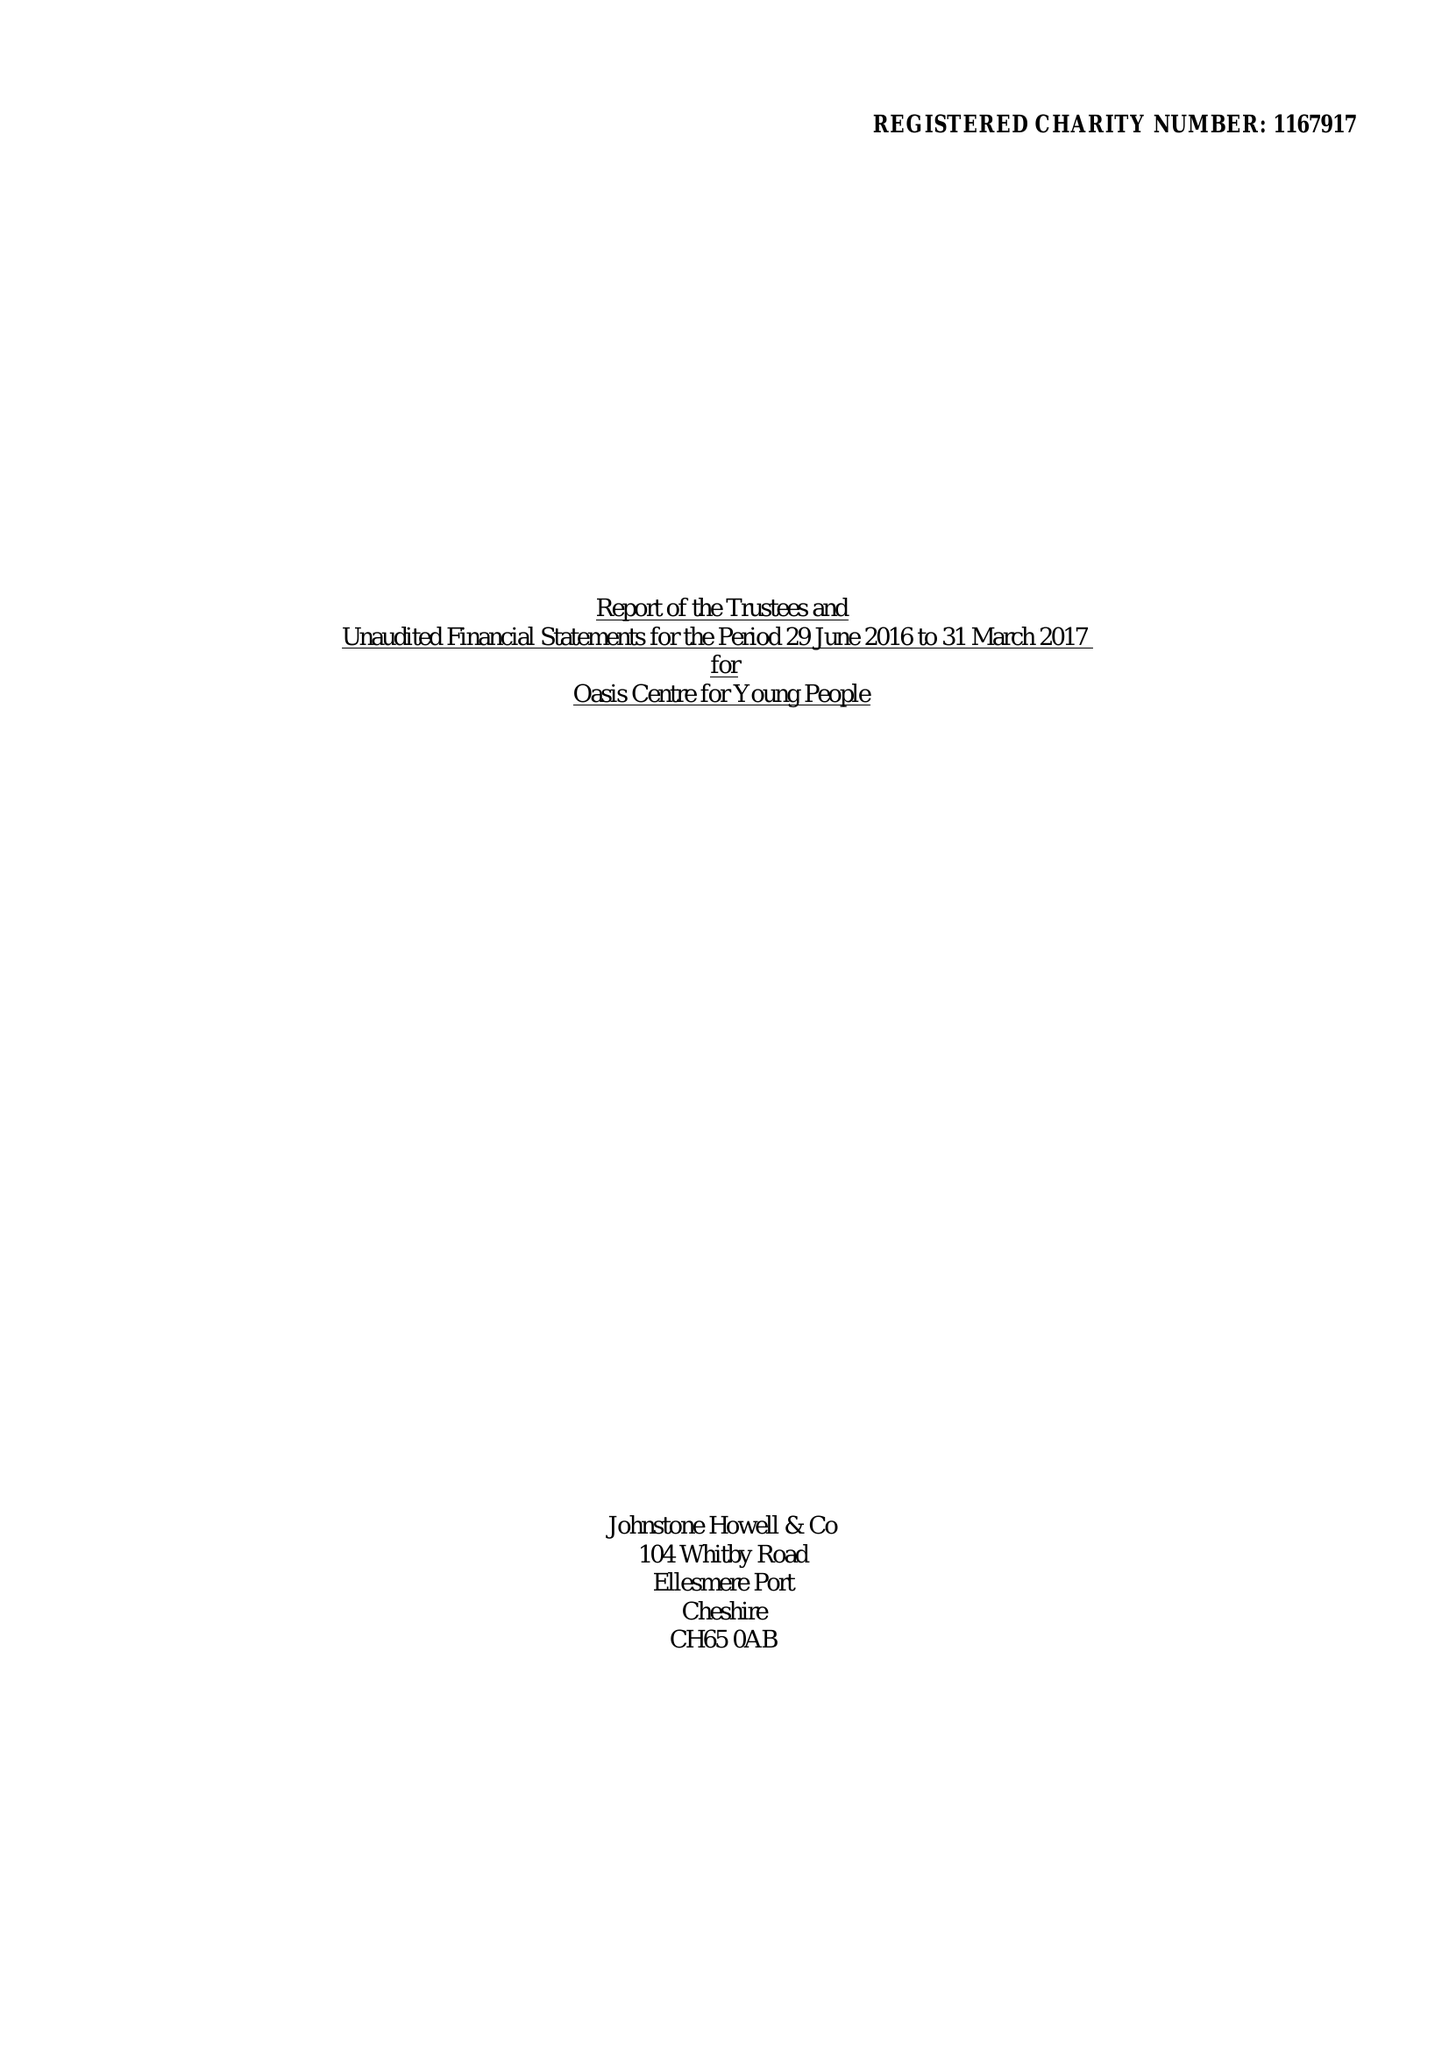What is the value for the report_date?
Answer the question using a single word or phrase. 2017-03-31 